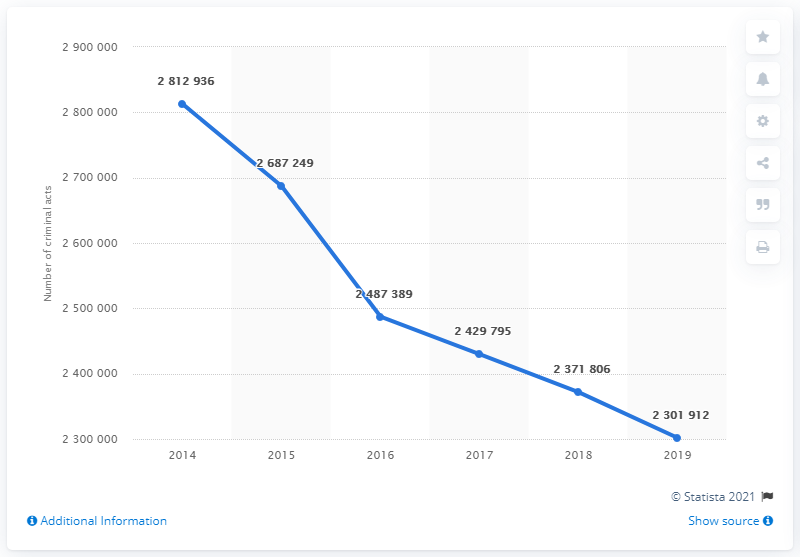Mention a couple of crucial points in this snapshot. The police reported a total of 281,293 crimes to the judicial authority in 2014. In 2019, the police reported a total of 230,191.2 crimes to the judicial authority. 